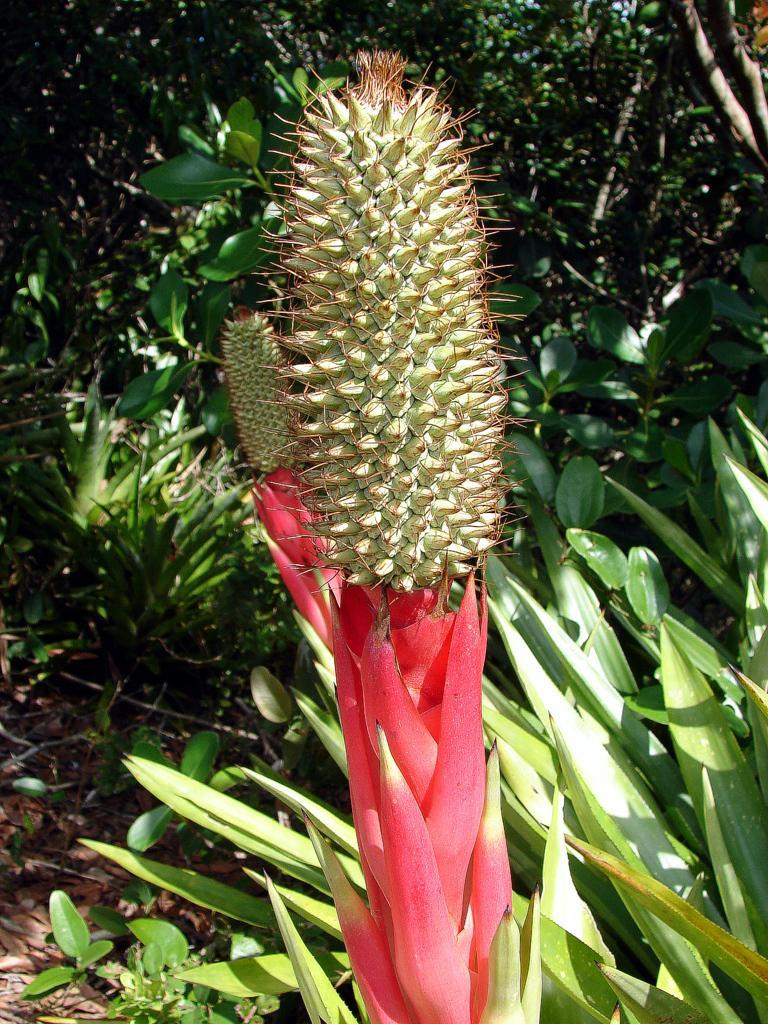What type of vegetation can be seen in the image? There are plants and trees in the image. Can you describe the plants and trees in more detail? Unfortunately, the facts provided do not give more specific details about the plants and trees. What is the setting or environment in which the plants and trees are located? The facts do not specify the setting or environment, so it cannot be determined from the information given. What type of prose is being recited by the plants in the image? There are no people or animals present in the image, let alone plants reciting prose. 